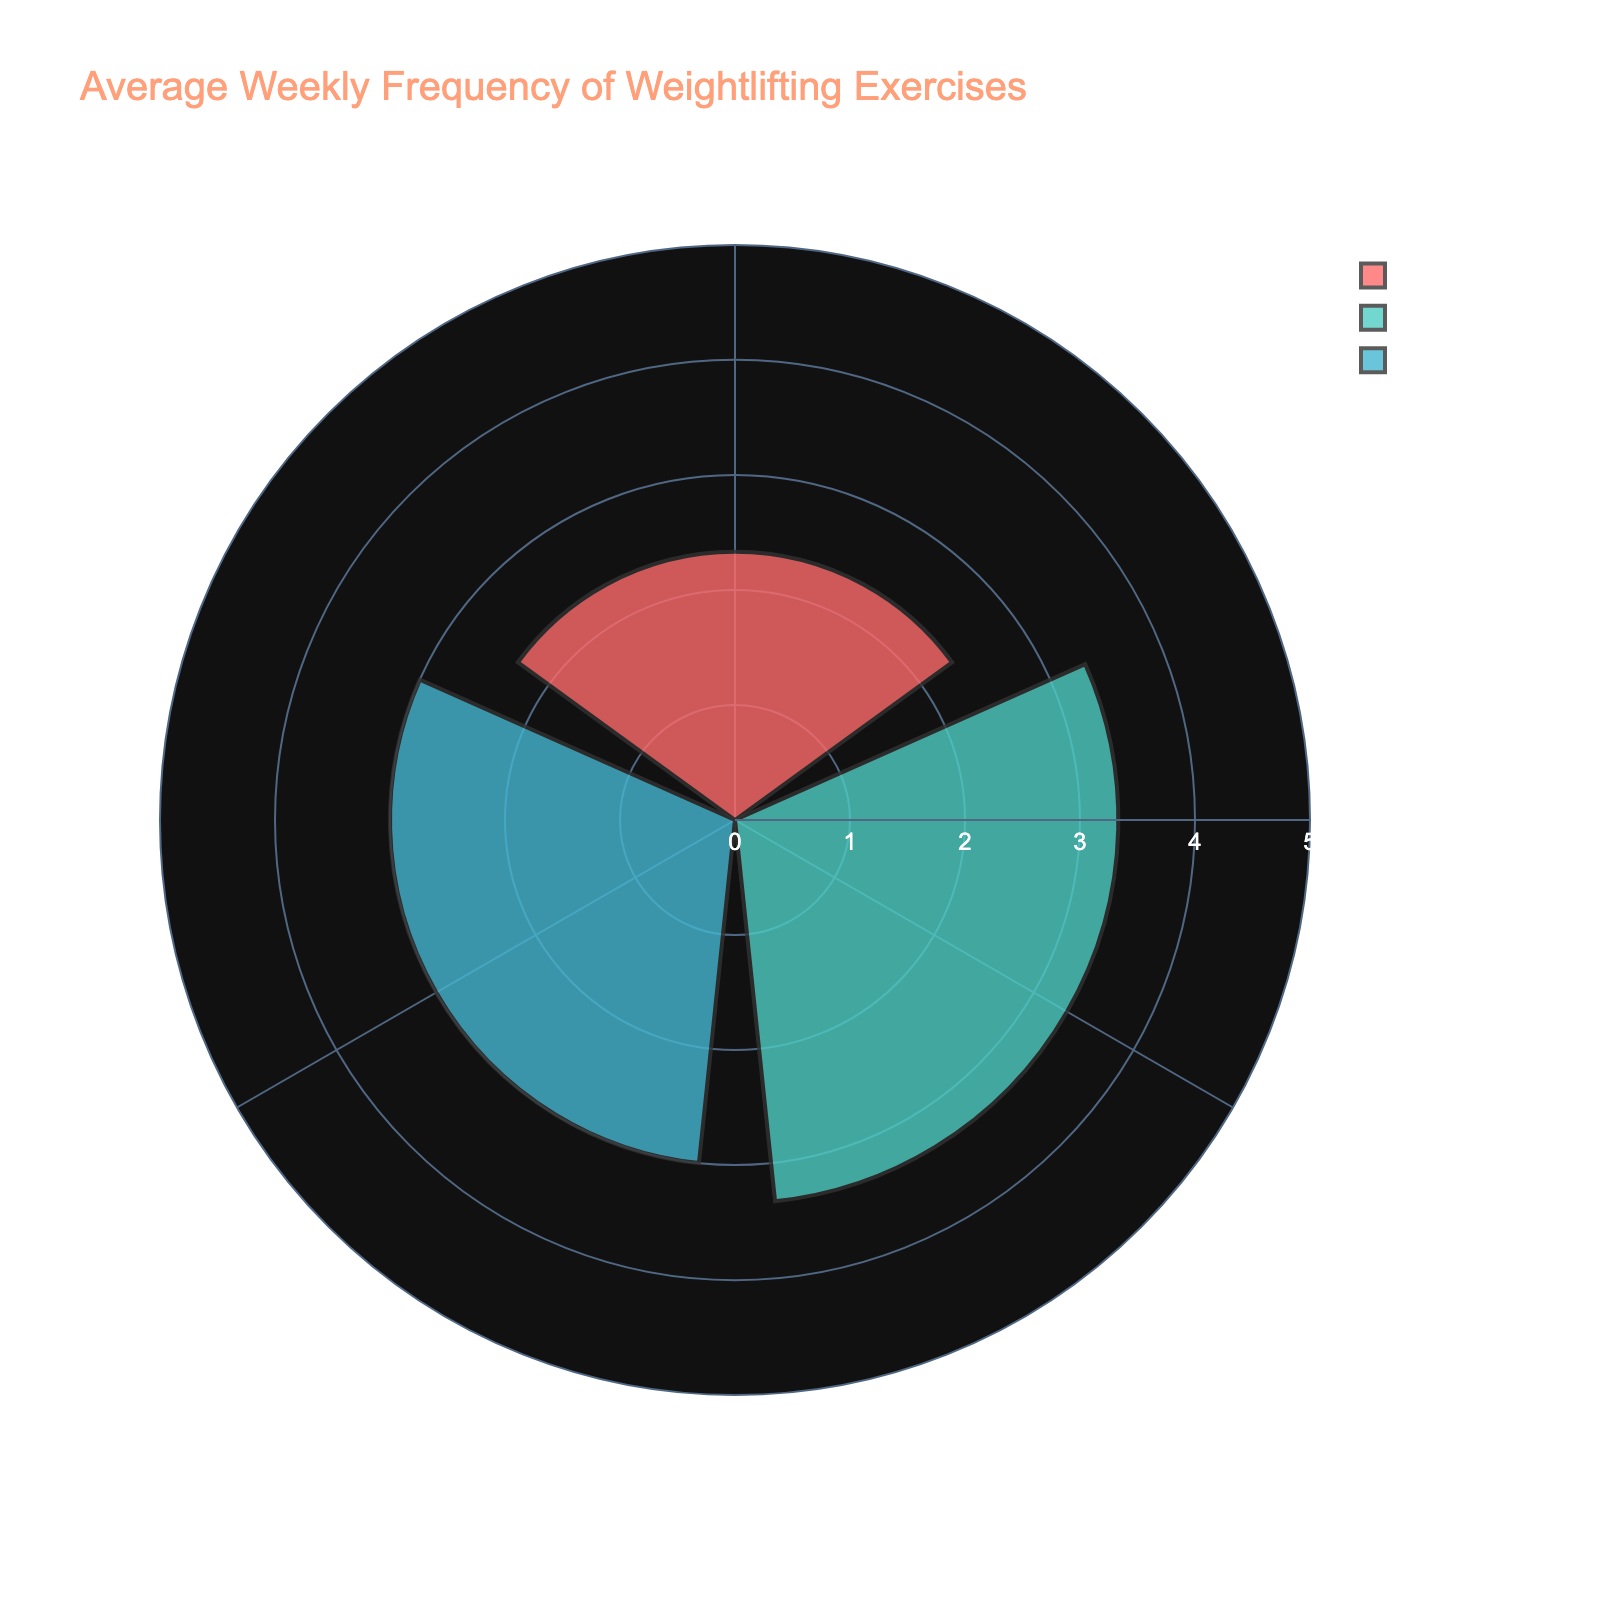What's the title of the rose chart? The title is typically located at the top of the figure and provides a brief description of what the chart represents.
Answer: Average Weekly Frequency of Weightlifting Exercises Which exercise type has the highest average frequency per week? By looking at the lengths of the bars or the radial distances, the exercise type with the largest bar represents the highest average frequency per week.
Answer: Hypertrophy How many exercise types are shown in the rose chart? Count the number of distinct categories or segments present in the chart.
Answer: Three What is the average frequency per week for Strength exercises? Locate the bar segment labeled "Strength" and note the radial distance corresponding to it.
Answer: 3 How does the average frequency of Endurance exercises compare to Hypertrophy exercises? Compare the radial lengths of the bars for Endurance and Hypertrophy segments. Hypertrophy has a longer bar than Endurance, indicating a higher average frequency.
Answer: Lower If you combine the average frequencies of Strength and Endurance exercises, what's the total? Add the average frequencies for Strength (3) and Endurance (2).
Answer: 5 What is the range of the radial axis in the chart? The range of the radial axis is indicated by the numbers at the radial ticks.
Answer: 0 to 5 Which exercise type has the smallest average frequency per week? Identify the segment with the shortest bar length, which indicates the lowest average frequency.
Answer: Endurance By how much does the average frequency of Hypertrophy exercises exceed that of Strength exercises? Subtract the average frequency of Strength (3) from Hypertrophy (4).
Answer: 1 In terms of average frequency per week, rank the exercise types from highest to lowest. Arrange the exercise types based on the lengths of their bars from longest to shortest.
Answer: Hypertrophy, Strength, Endurance 